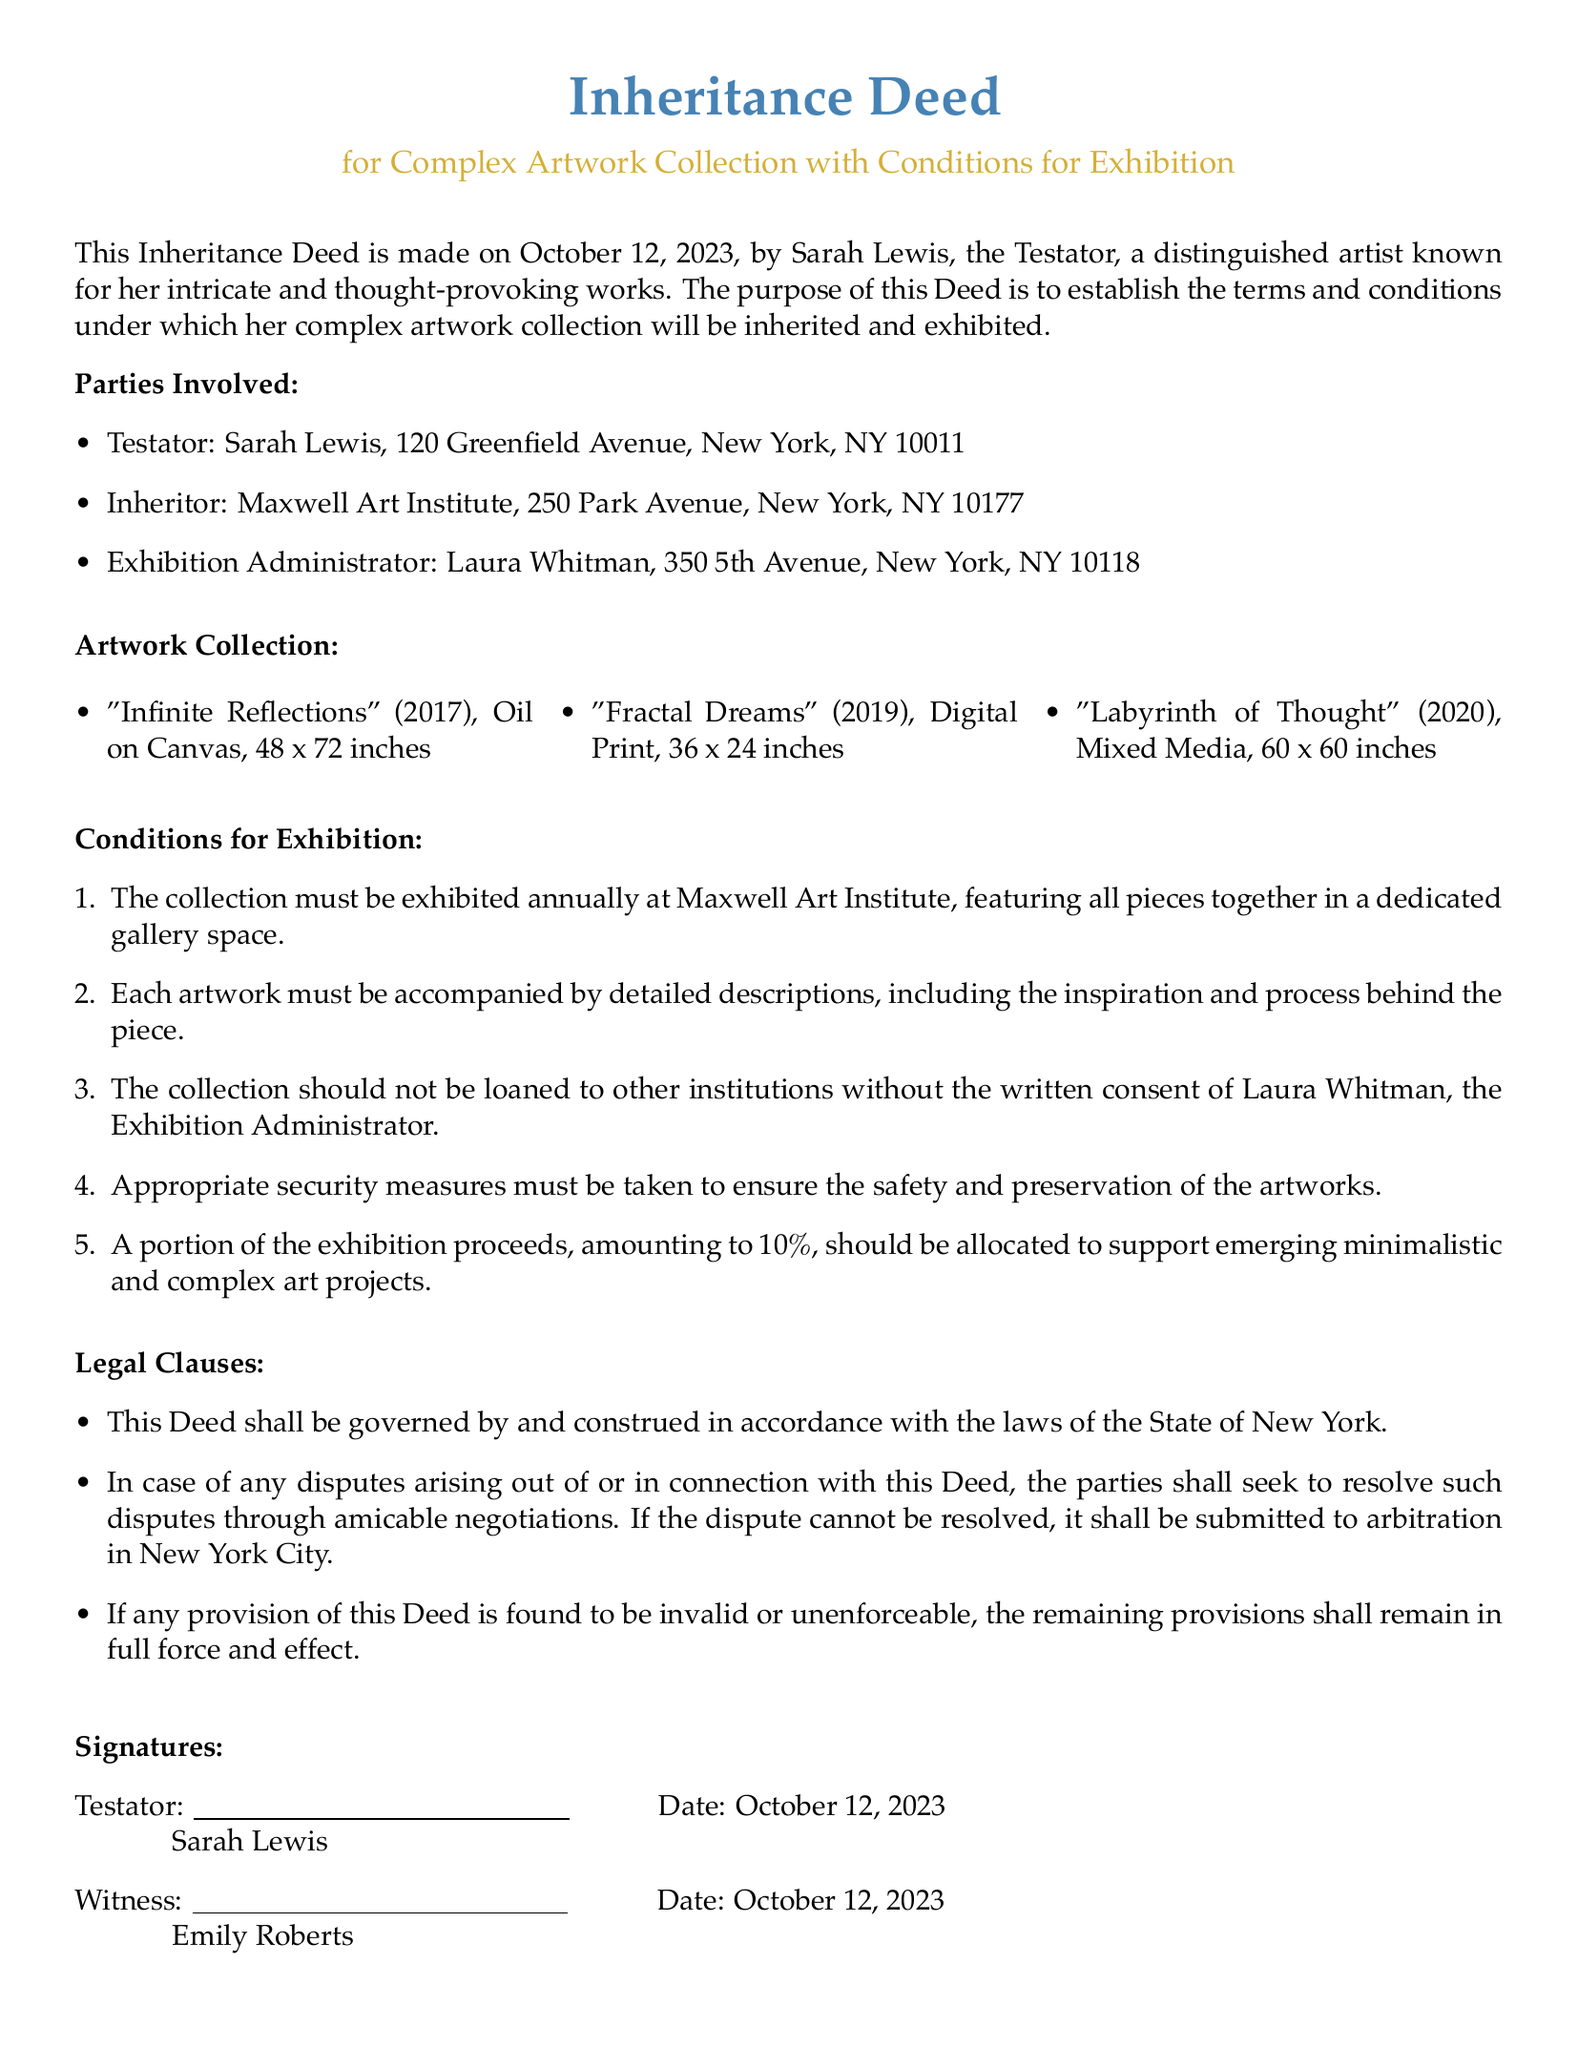What is the date of the Inheritance Deed? The date mentioned in the document is the official date when the Inheritance Deed was created.
Answer: October 12, 2023 Who is the Testator? The Testator is the individual who makes the Inheritance Deed; in this case, it is the person associated with the artwork collection.
Answer: Sarah Lewis What is the name of the inheritor organization? This refers to the entity that will receive the artwork collection as stated in the Inheritance Deed.
Answer: Maxwell Art Institute How many pieces are in the artwork collection? The count of the artworks listed under the artwork collection section of the document.
Answer: Three What is the required annual percentage allocation from exhibition proceeds? This percentage is specified in the conditions to support art projects and is derived from the exhibition revenues.
Answer: 10% What must accompany each artwork during the exhibition? This is a requirement specified in the conditions to enhance understanding of the artworks on display.
Answer: Detailed descriptions Who is responsible for administering the exhibitions? The individual named in the document who manages the exhibition logistics and policies.
Answer: Laura Whitman What should happen if disputes arise from this Deed? This outlines how any disagreements related to the Inheritance Deed are to be handled as per legal clauses.
Answer: Amicable negotiations 